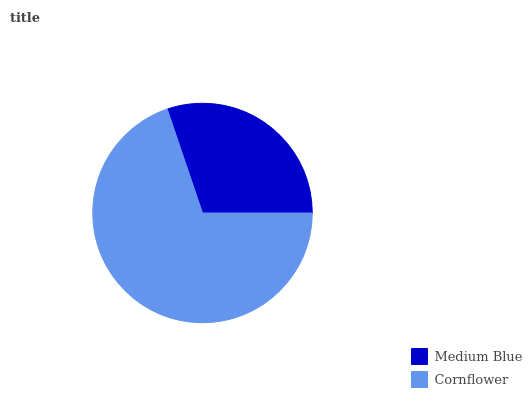Is Medium Blue the minimum?
Answer yes or no. Yes. Is Cornflower the maximum?
Answer yes or no. Yes. Is Cornflower the minimum?
Answer yes or no. No. Is Cornflower greater than Medium Blue?
Answer yes or no. Yes. Is Medium Blue less than Cornflower?
Answer yes or no. Yes. Is Medium Blue greater than Cornflower?
Answer yes or no. No. Is Cornflower less than Medium Blue?
Answer yes or no. No. Is Cornflower the high median?
Answer yes or no. Yes. Is Medium Blue the low median?
Answer yes or no. Yes. Is Medium Blue the high median?
Answer yes or no. No. Is Cornflower the low median?
Answer yes or no. No. 